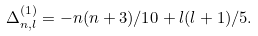<formula> <loc_0><loc_0><loc_500><loc_500>\Delta _ { n , l } ^ { ( 1 ) } = - n ( n + 3 ) / 1 0 + l ( l + 1 ) / 5 .</formula> 